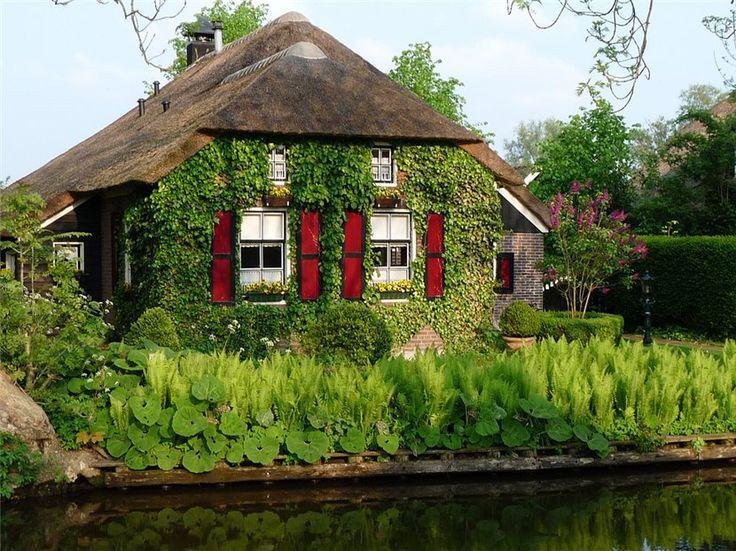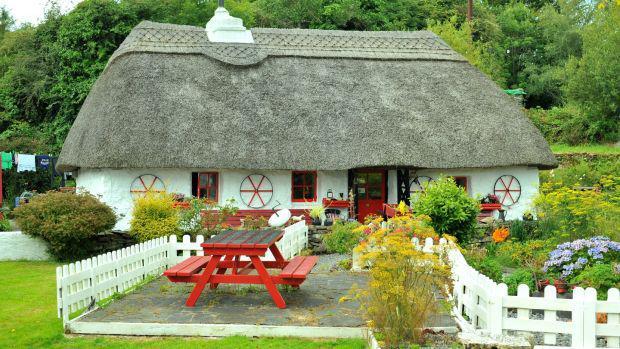The first image is the image on the left, the second image is the image on the right. Analyze the images presented: Is the assertion "The walls of one of the thatched houses is covered with a climbing vine, maybe ivy." valid? Answer yes or no. Yes. The first image is the image on the left, the second image is the image on the right. For the images displayed, is the sentence "There are two chimneys." factually correct? Answer yes or no. Yes. 